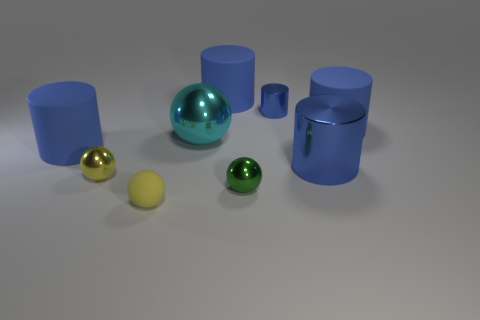Subtract all big blue metal cylinders. How many cylinders are left? 4 Add 1 yellow things. How many objects exist? 10 Subtract 1 spheres. How many spheres are left? 3 Subtract all spheres. How many objects are left? 5 Subtract all brown spheres. Subtract all blue cylinders. How many spheres are left? 4 Subtract all tiny yellow balls. Subtract all small green objects. How many objects are left? 6 Add 3 cyan things. How many cyan things are left? 4 Add 9 tiny purple metallic objects. How many tiny purple metallic objects exist? 9 Subtract 0 red cylinders. How many objects are left? 9 